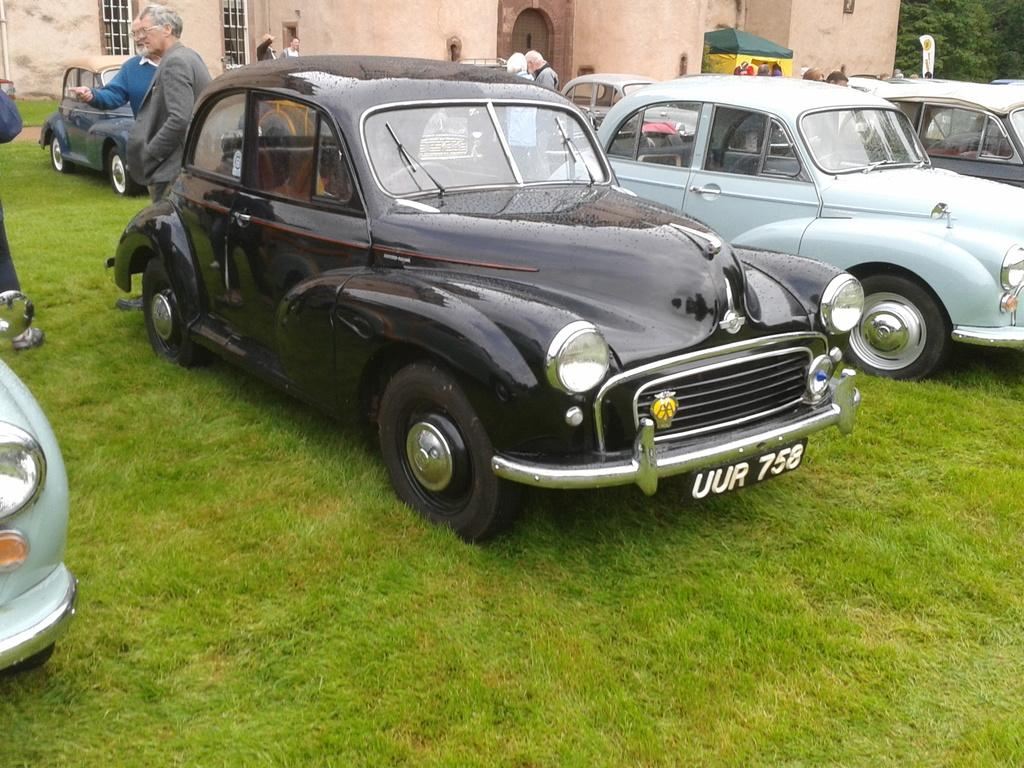What can be seen parked in the image? There are vehicles parked in the image. What are some people doing in the image? Some people are standing, and others are walking in the image. What type of building is visible in the image? There is a cream-colored building in the image. What kind of vegetation is present in the image? There are trees in green color in the image. What type of comb is being used by the people in the image? There is no comb visible in the image; people are standing or walking. Can you tell me how many cracks are present in the cream-colored building? There is no mention of cracks in the cream-colored building in the image. 